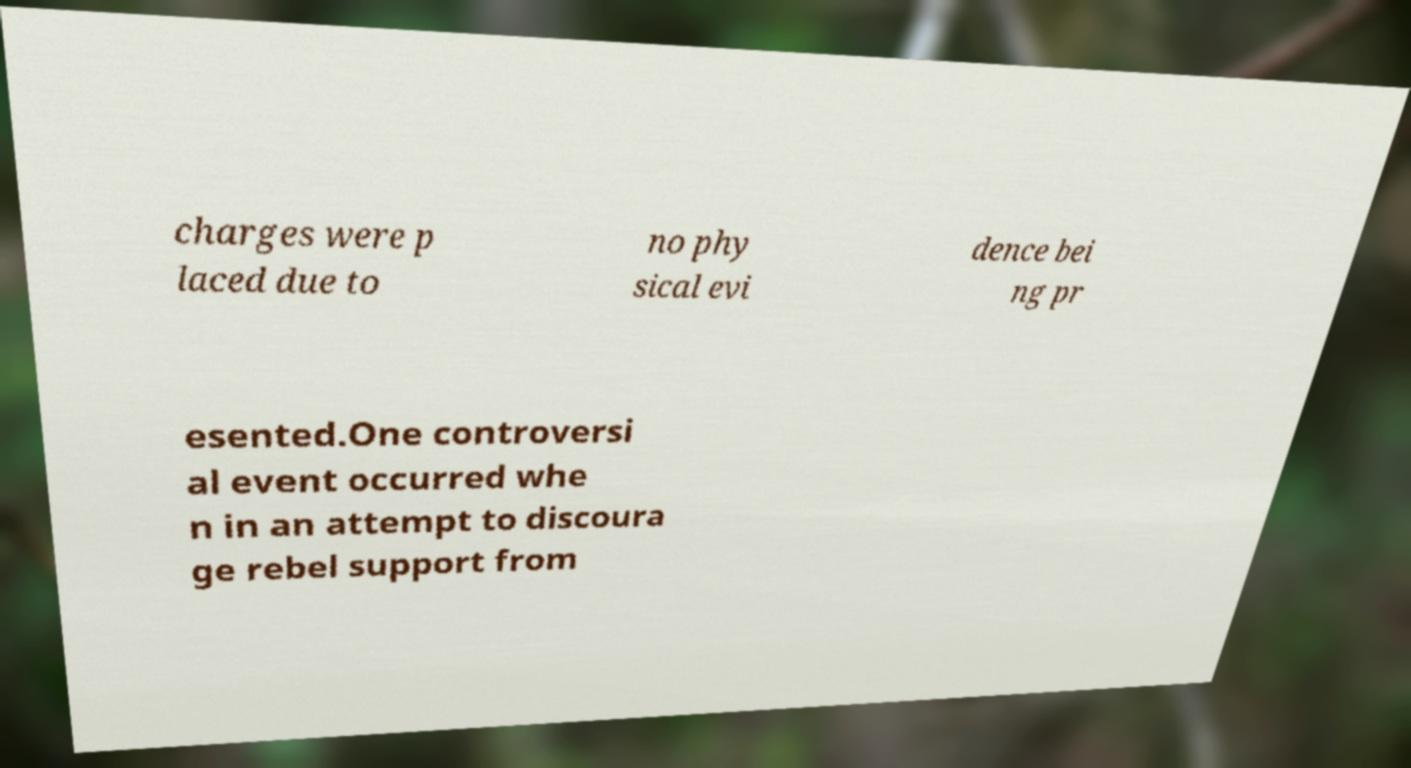Please identify and transcribe the text found in this image. charges were p laced due to no phy sical evi dence bei ng pr esented.One controversi al event occurred whe n in an attempt to discoura ge rebel support from 